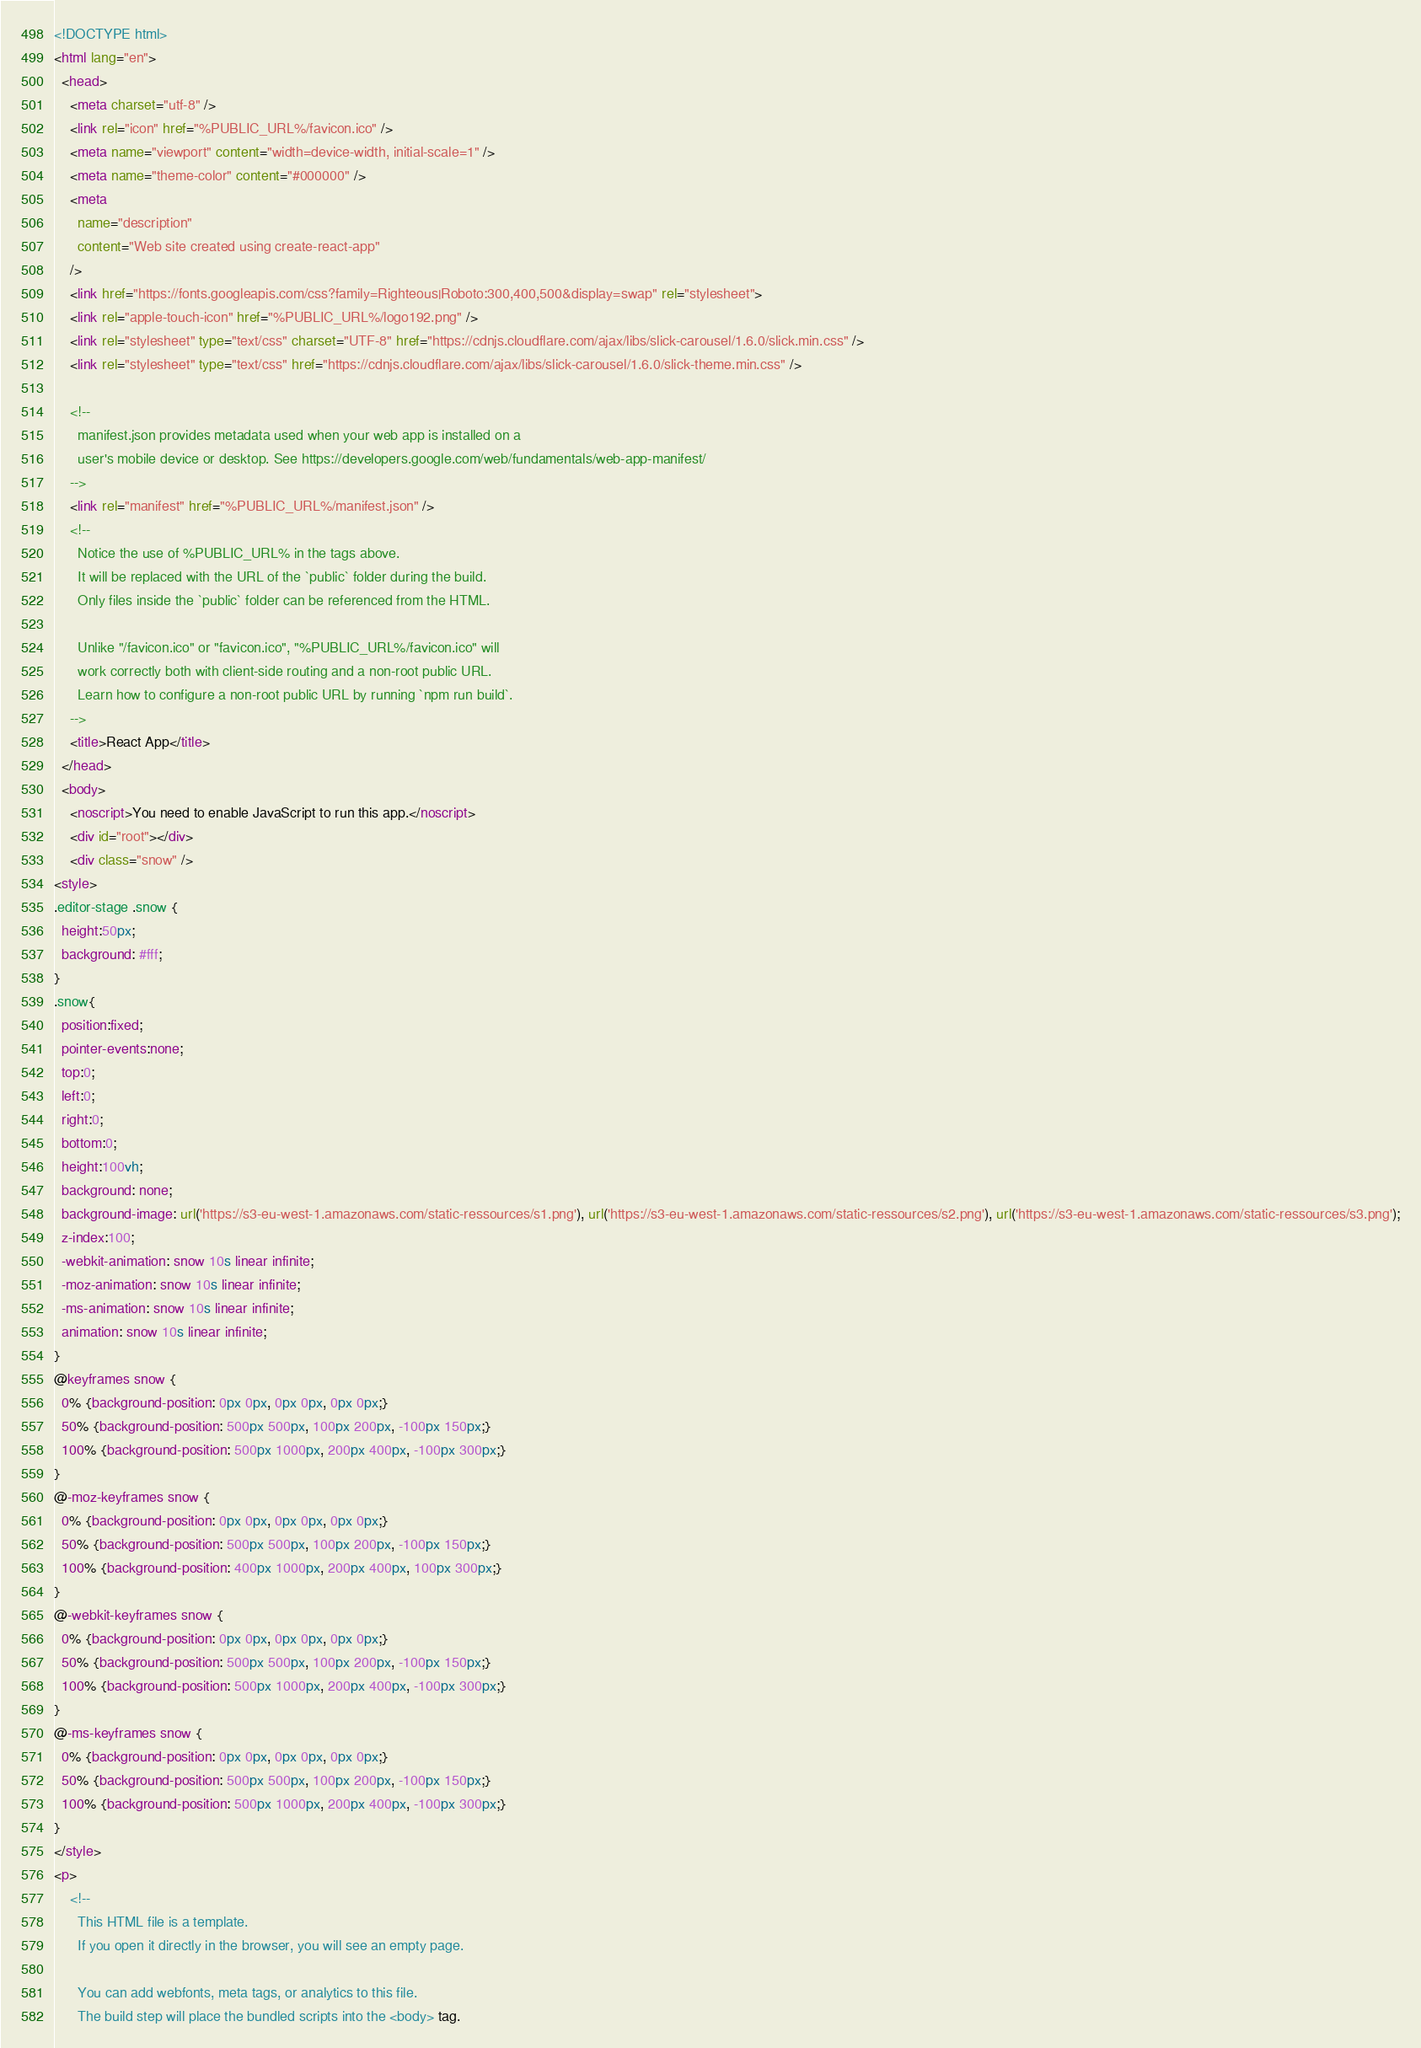Convert code to text. <code><loc_0><loc_0><loc_500><loc_500><_HTML_><!DOCTYPE html>
<html lang="en">
  <head>
    <meta charset="utf-8" />
    <link rel="icon" href="%PUBLIC_URL%/favicon.ico" />
    <meta name="viewport" content="width=device-width, initial-scale=1" />
    <meta name="theme-color" content="#000000" />
    <meta
      name="description"
      content="Web site created using create-react-app"
    />
    <link href="https://fonts.googleapis.com/css?family=Righteous|Roboto:300,400,500&display=swap" rel="stylesheet">
    <link rel="apple-touch-icon" href="%PUBLIC_URL%/logo192.png" />
    <link rel="stylesheet" type="text/css" charset="UTF-8" href="https://cdnjs.cloudflare.com/ajax/libs/slick-carousel/1.6.0/slick.min.css" />
    <link rel="stylesheet" type="text/css" href="https://cdnjs.cloudflare.com/ajax/libs/slick-carousel/1.6.0/slick-theme.min.css" />

    <!--
      manifest.json provides metadata used when your web app is installed on a
      user's mobile device or desktop. See https://developers.google.com/web/fundamentals/web-app-manifest/
    -->
    <link rel="manifest" href="%PUBLIC_URL%/manifest.json" />
    <!--
      Notice the use of %PUBLIC_URL% in the tags above.
      It will be replaced with the URL of the `public` folder during the build.
      Only files inside the `public` folder can be referenced from the HTML.

      Unlike "/favicon.ico" or "favicon.ico", "%PUBLIC_URL%/favicon.ico" will
      work correctly both with client-side routing and a non-root public URL.
      Learn how to configure a non-root public URL by running `npm run build`.
    -->
    <title>React App</title>
  </head>
  <body>
    <noscript>You need to enable JavaScript to run this app.</noscript>
    <div id="root"></div>
    <div class="snow" />
<style>
.editor-stage .snow {
  height:50px;
  background: #fff;
}
.snow{
  position:fixed;
  pointer-events:none;
  top:0;
  left:0;
  right:0;
  bottom:0;
  height:100vh;
  background: none;
  background-image: url('https://s3-eu-west-1.amazonaws.com/static-ressources/s1.png'), url('https://s3-eu-west-1.amazonaws.com/static-ressources/s2.png'), url('https://s3-eu-west-1.amazonaws.com/static-ressources/s3.png');
  z-index:100;
  -webkit-animation: snow 10s linear infinite;
  -moz-animation: snow 10s linear infinite;
  -ms-animation: snow 10s linear infinite;
  animation: snow 10s linear infinite;
}
@keyframes snow {
  0% {background-position: 0px 0px, 0px 0px, 0px 0px;}
  50% {background-position: 500px 500px, 100px 200px, -100px 150px;}
  100% {background-position: 500px 1000px, 200px 400px, -100px 300px;}
}
@-moz-keyframes snow {
  0% {background-position: 0px 0px, 0px 0px, 0px 0px;}
  50% {background-position: 500px 500px, 100px 200px, -100px 150px;}
  100% {background-position: 400px 1000px, 200px 400px, 100px 300px;}
}
@-webkit-keyframes snow {
  0% {background-position: 0px 0px, 0px 0px, 0px 0px;}
  50% {background-position: 500px 500px, 100px 200px, -100px 150px;}
  100% {background-position: 500px 1000px, 200px 400px, -100px 300px;}
}
@-ms-keyframes snow {
  0% {background-position: 0px 0px, 0px 0px, 0px 0px;}
  50% {background-position: 500px 500px, 100px 200px, -100px 150px;}
  100% {background-position: 500px 1000px, 200px 400px, -100px 300px;}
}
</style>
<p>
    <!--
      This HTML file is a template.
      If you open it directly in the browser, you will see an empty page.

      You can add webfonts, meta tags, or analytics to this file.
      The build step will place the bundled scripts into the <body> tag.
</code> 